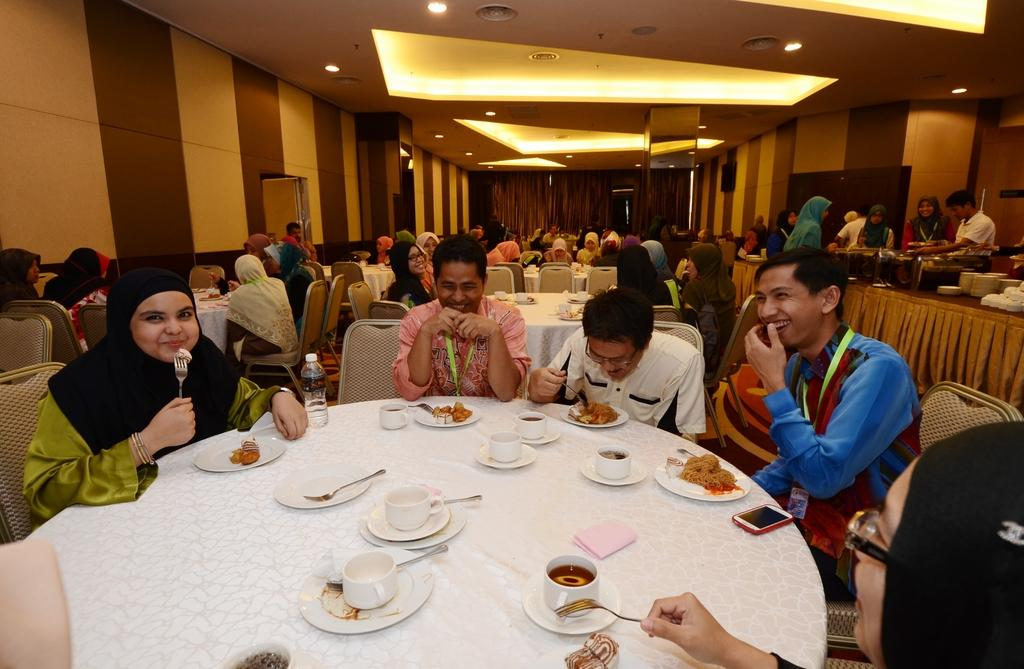What are the people in the image doing? The people in the image are sitting on chairs around a table. What is on the table that they are sitting around? There is a plate with food, cups, saucers, forks, and bottles on the table. What might the people be using to eat the food on the plate? The forks on the table might be used to eat the food. What type of hammer is being used to copy the size of the food on the plate? There is no hammer or copying activity present in the image. What is the size of the hammer being used to copy the size of the food on the plate? There is no hammer or copying activity present in the image, so it is not possible to determine the size of a hammer. 